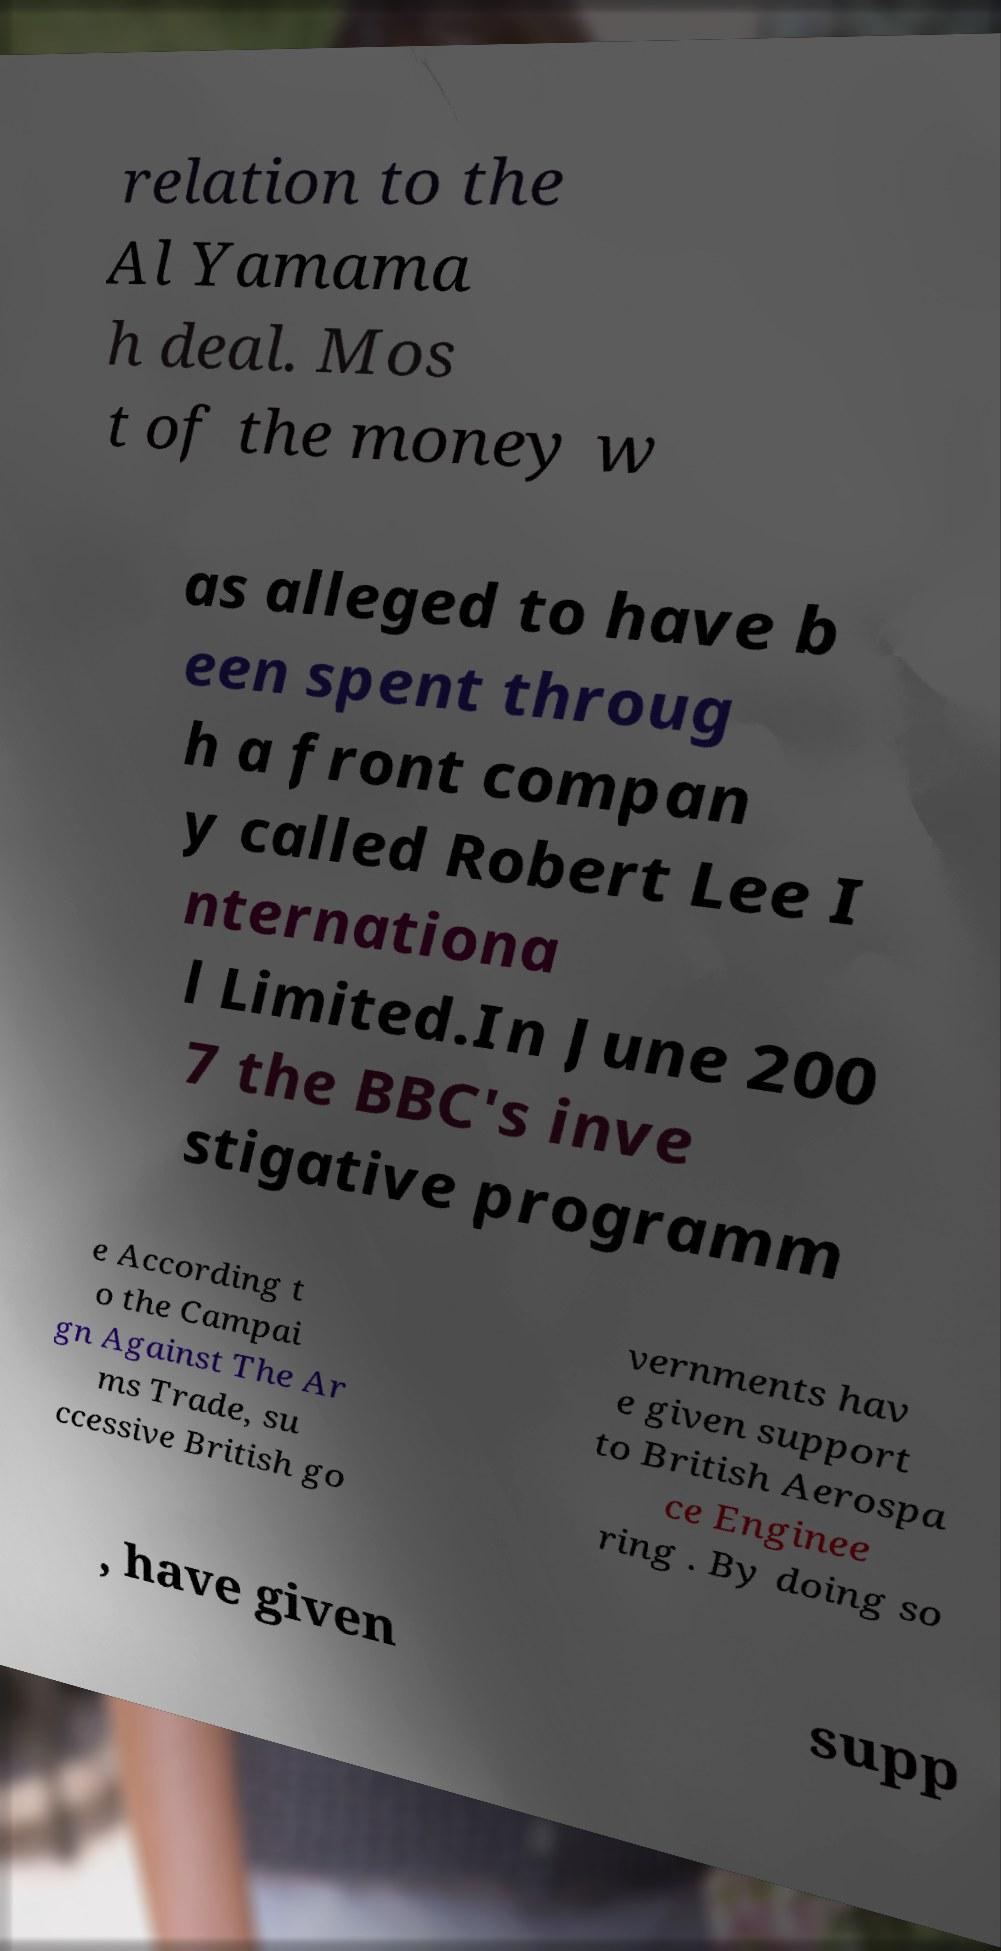Can you read and provide the text displayed in the image?This photo seems to have some interesting text. Can you extract and type it out for me? relation to the Al Yamama h deal. Mos t of the money w as alleged to have b een spent throug h a front compan y called Robert Lee I nternationa l Limited.In June 200 7 the BBC's inve stigative programm e According t o the Campai gn Against The Ar ms Trade, su ccessive British go vernments hav e given support to British Aerospa ce Enginee ring . By doing so , have given supp 